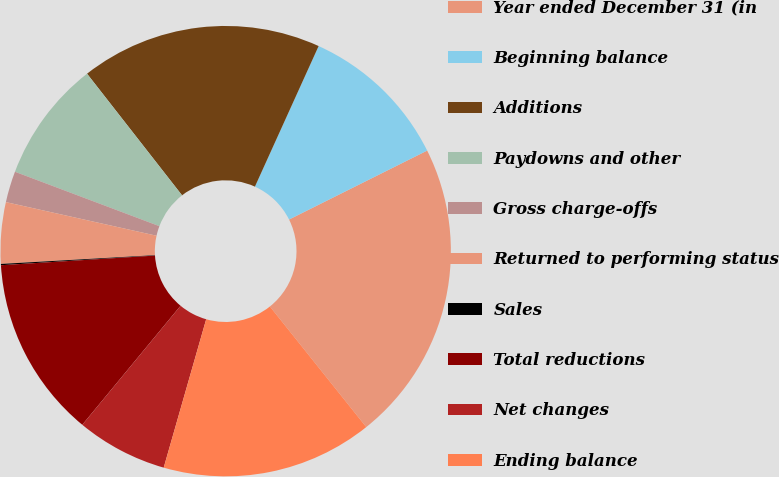Convert chart. <chart><loc_0><loc_0><loc_500><loc_500><pie_chart><fcel>Year ended December 31 (in<fcel>Beginning balance<fcel>Additions<fcel>Paydowns and other<fcel>Gross charge-offs<fcel>Returned to performing status<fcel>Sales<fcel>Total reductions<fcel>Net changes<fcel>Ending balance<nl><fcel>21.64%<fcel>10.86%<fcel>17.33%<fcel>8.71%<fcel>2.24%<fcel>4.4%<fcel>0.09%<fcel>13.02%<fcel>6.55%<fcel>15.17%<nl></chart> 